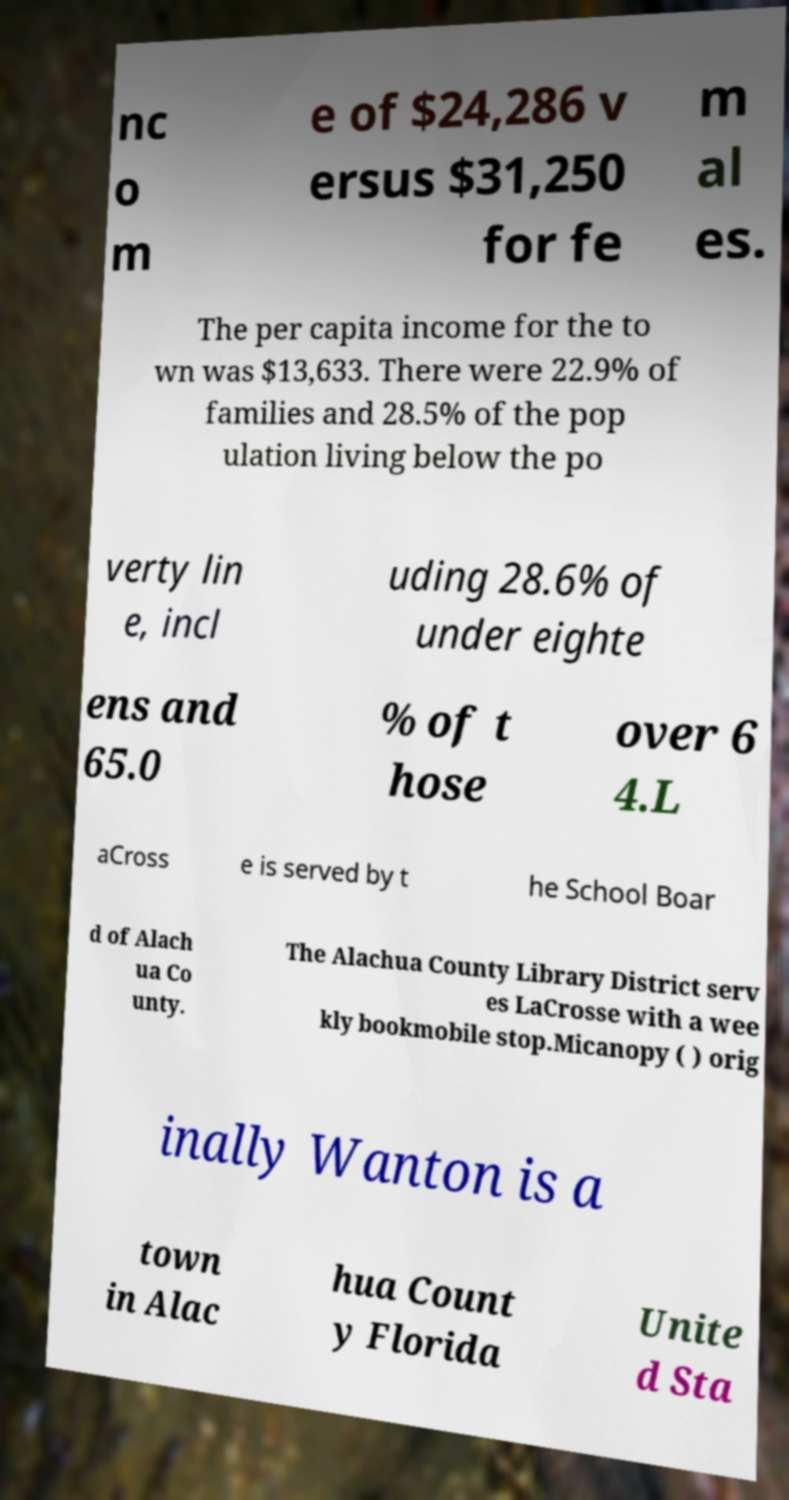There's text embedded in this image that I need extracted. Can you transcribe it verbatim? nc o m e of $24,286 v ersus $31,250 for fe m al es. The per capita income for the to wn was $13,633. There were 22.9% of families and 28.5% of the pop ulation living below the po verty lin e, incl uding 28.6% of under eighte ens and 65.0 % of t hose over 6 4.L aCross e is served by t he School Boar d of Alach ua Co unty. The Alachua County Library District serv es LaCrosse with a wee kly bookmobile stop.Micanopy ( ) orig inally Wanton is a town in Alac hua Count y Florida Unite d Sta 